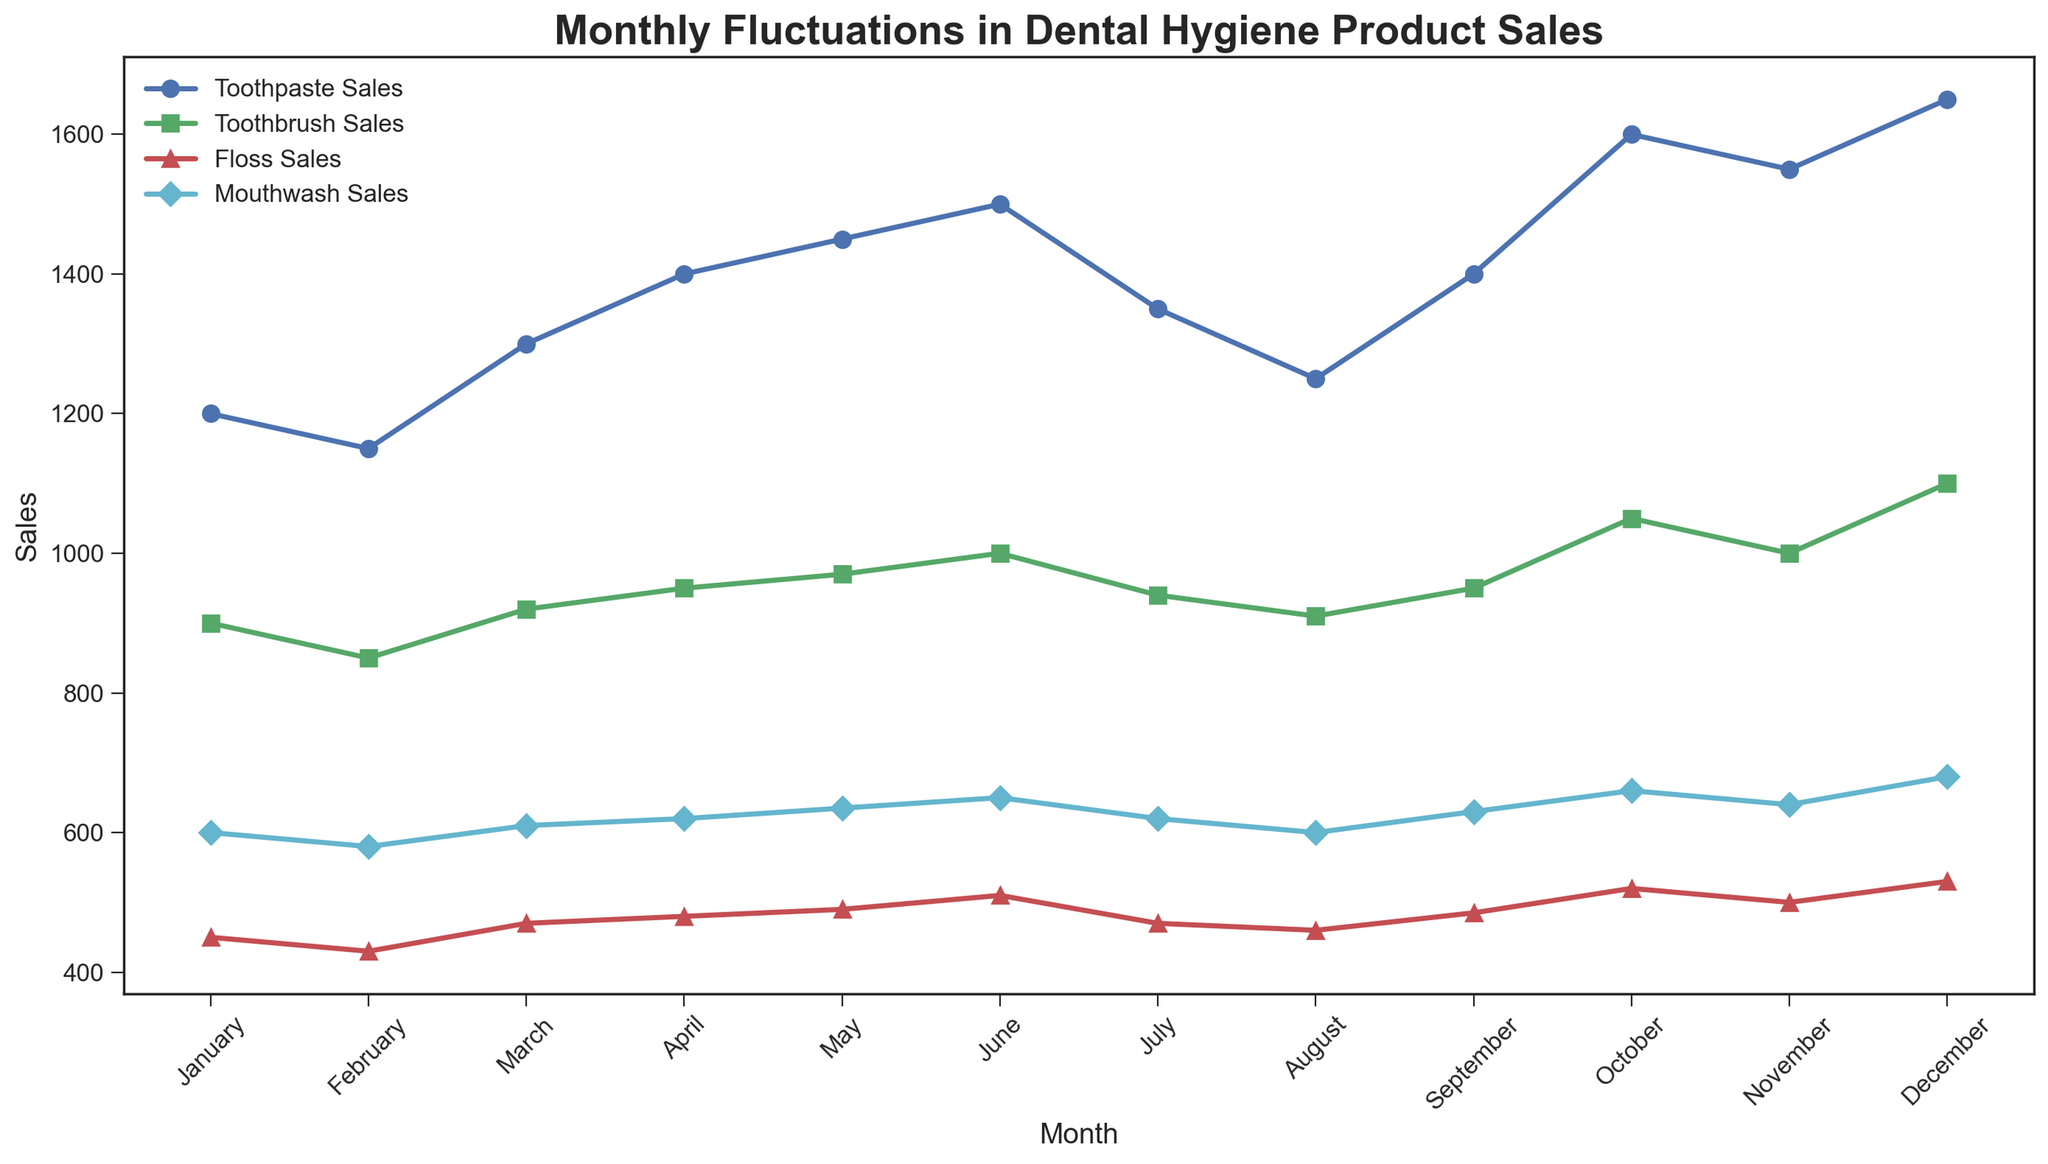Which month had the highest sales for toothpaste? By visually inspecting the line corresponding to toothpaste sales, we see the highest point occurs in December.
Answer: December How many months had floss sales greater than 500 units? Identify the months where the floss sales line is above the 500-unit mark on the y-axis; these months are October, November, and December. Thus, there are 3 such months.
Answer: 3 Which product showed the most significant rise in sales from January to December? Compare the initial and final points of sales lines for all four products. The biggest difference is in toothpaste sales, which increases from 1200 to 1650 units.
Answer: Toothpaste In which month did toothbrush sales equal 1000 units? Look for the month where the toothbrush sales marker aligns with the 1000-unit mark; this occurs in June and November.
Answer: June and November What is the combined sales of all products in March? Sum the sales of all four products in March: Toothpaste (1300) + Toothbrush (920) + Floss (470) + Mouthwash (610) = 3300 units.
Answer: 3300 Which product had the least overall variation in sales over the year? Observe the relative smoothness and range of fluctuation for each product's line over 12 months. Floss sales have the smallest fluctuations.
Answer: Floss Compare the sales of mouthwash in February and October. Which month had higher sales? Check the sales values for mouthwash in both months. February has 580 units, and October has 660 units. October has higher sales.
Answer: October What is the average monthly sales for toothbrushes from January to December? Add up the sales of toothbrushes over 12 months and divide by 12: (900+850+920+950+970+1000+940+910+950+1050+1000+1100)/12 = 970.
Answer: 970 Did any product's sales decrease from March to June? Track each product’s sales from March to June; none of the four products show a decreasing trend over these months.
Answer: No 